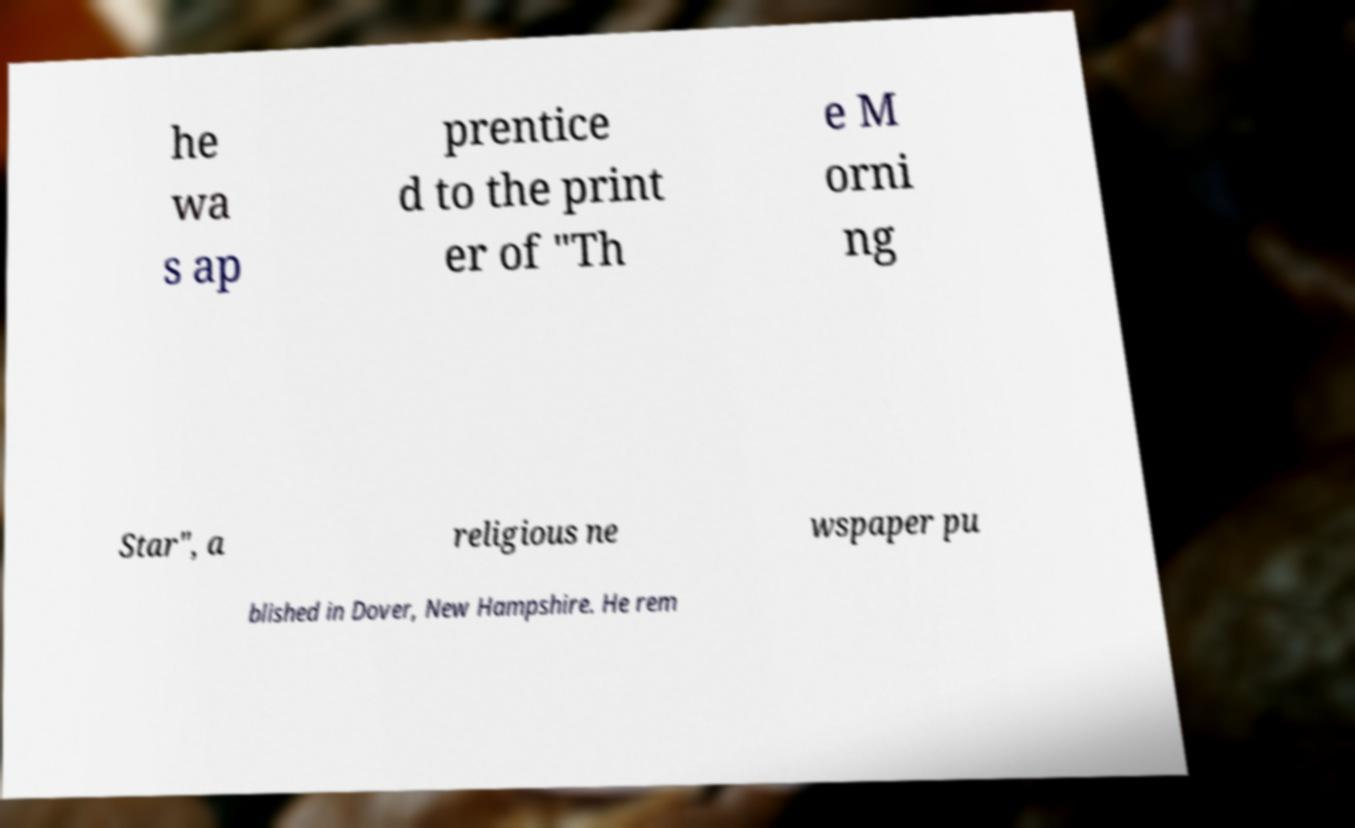For documentation purposes, I need the text within this image transcribed. Could you provide that? he wa s ap prentice d to the print er of "Th e M orni ng Star", a religious ne wspaper pu blished in Dover, New Hampshire. He rem 